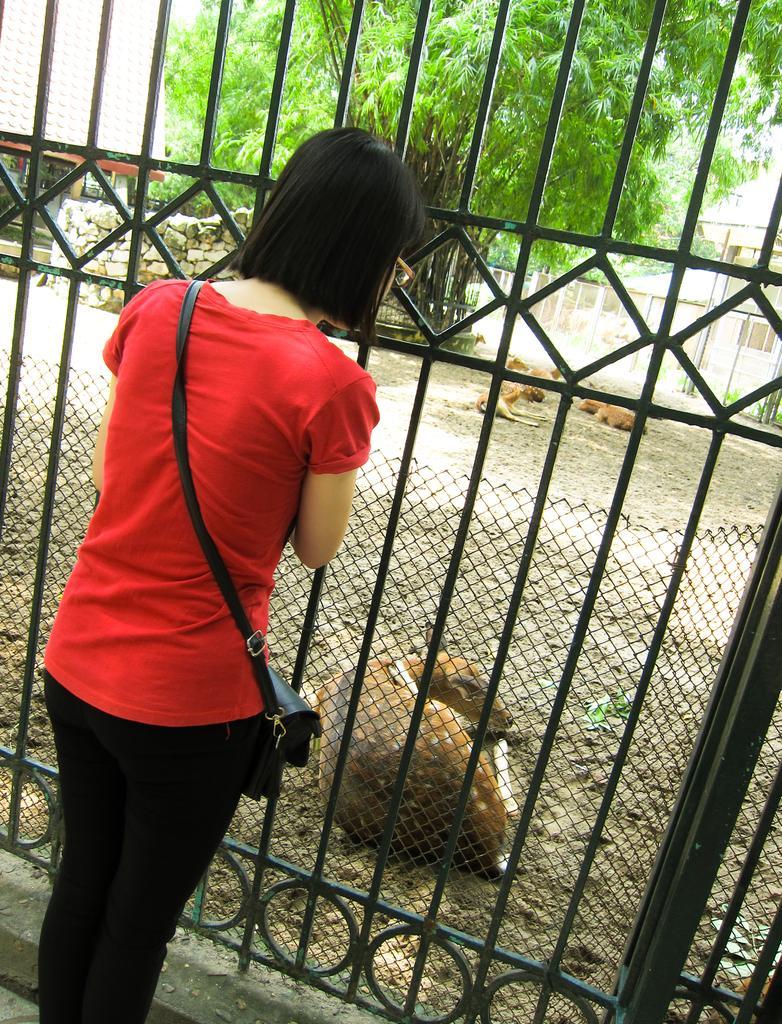How would you summarize this image in a sentence or two? In this image I can see a woman standing in front of a gate. The woman is wearing red color top, black color pant and carrying a bag. Here I can see some animals are sitting on the ground. In the background I can see trees and other objects. 